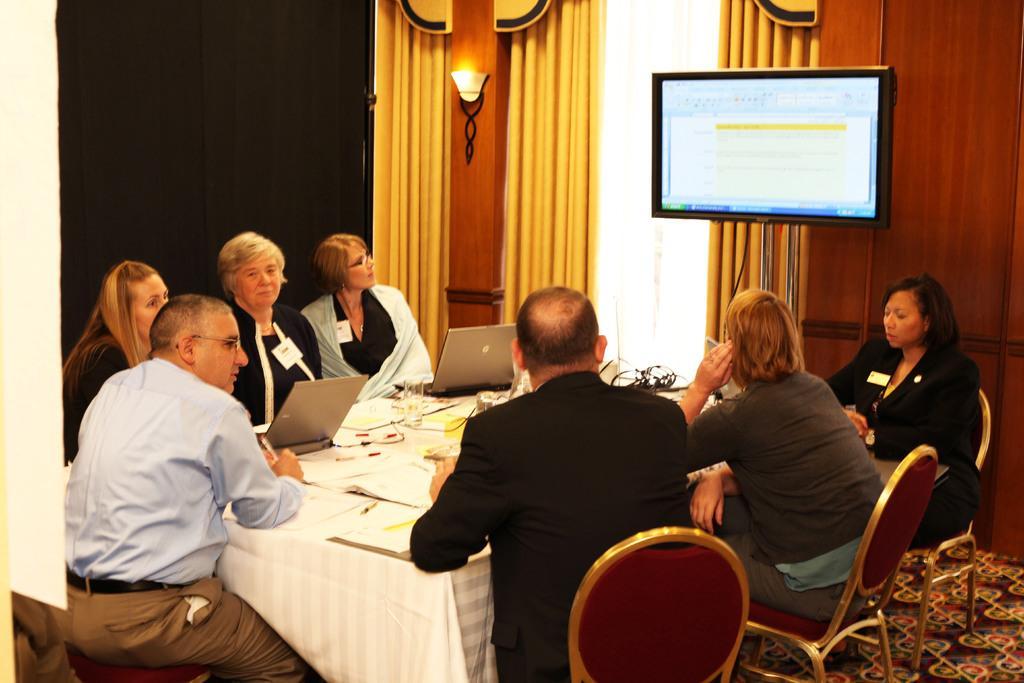In one or two sentences, can you explain what this image depicts? There are persons in different color dresses, sitting on chairs around a table, on which there are laptops, documents and other objects. In the background, there is a screen arranged, there is a light attached to the wall and there are curtains. 